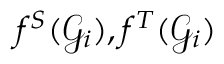<formula> <loc_0><loc_0><loc_500><loc_500>f ^ { S } ( { \mathcal { G } } _ { i } ) , f ^ { T } ( { \mathcal { G } } _ { i } )</formula> 